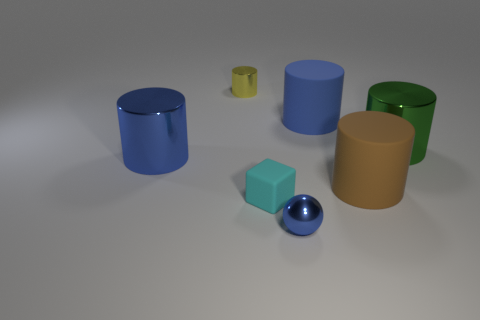Subtract 2 cylinders. How many cylinders are left? 3 Subtract all brown cylinders. How many cylinders are left? 4 Subtract all tiny metal cylinders. How many cylinders are left? 4 Subtract all gray cylinders. Subtract all green blocks. How many cylinders are left? 5 Add 1 large metallic cylinders. How many objects exist? 8 Subtract all cubes. How many objects are left? 6 Add 3 large brown shiny balls. How many large brown shiny balls exist? 3 Subtract 0 brown balls. How many objects are left? 7 Subtract all yellow metallic things. Subtract all large green metallic cylinders. How many objects are left? 5 Add 2 small yellow metal objects. How many small yellow metal objects are left? 3 